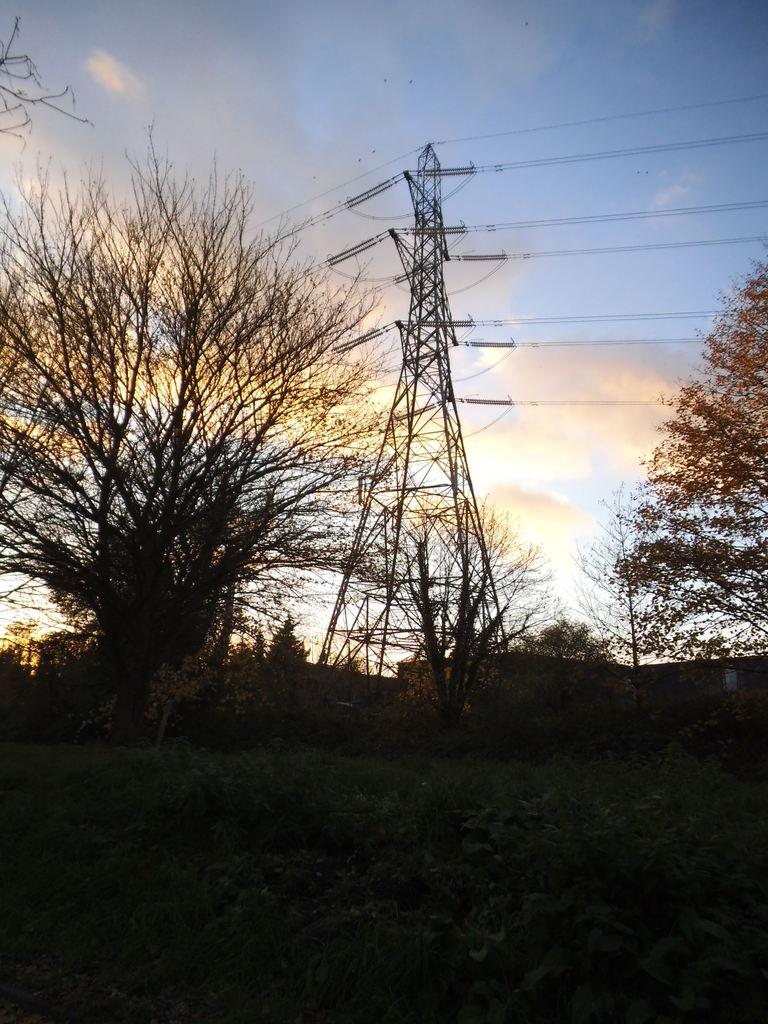What type of vegetation can be seen in the image? There are shrubs and trees in the image. What structure is present in the image? There is a tower in the image. What else can be seen in the image besides the vegetation and tower? There are wires in the image. What is visible in the background of the image? The sky is visible in the background of the image. What type of vegetable is being cooked in the image? There is no vegetable being cooked in the image. What time is it according to the clock in the image? There is no clock present in the image. 